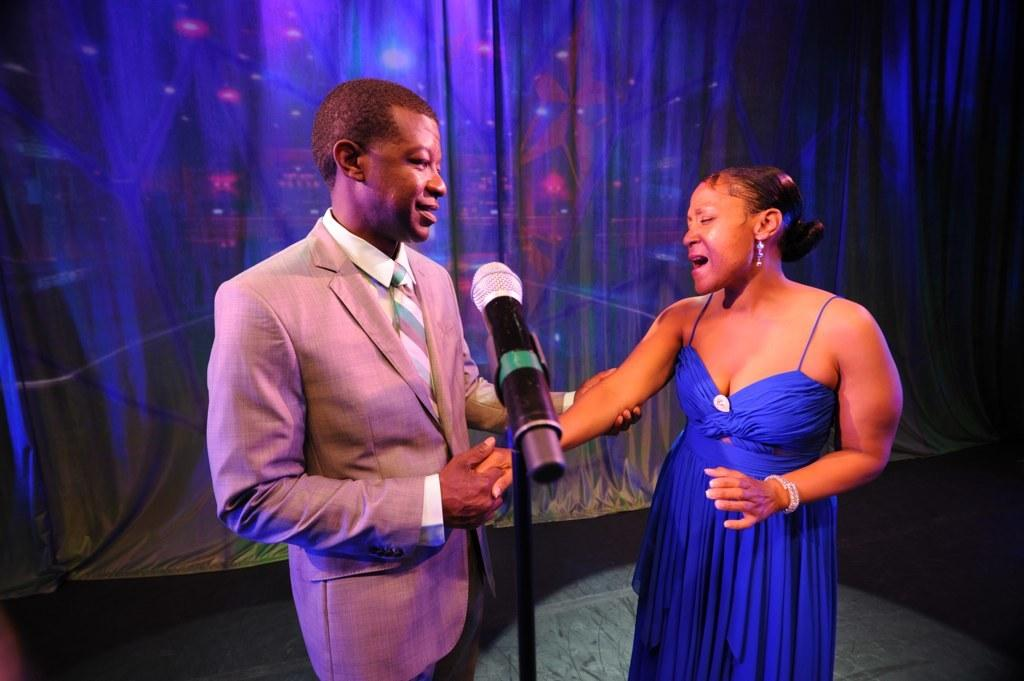What is the person in the image wearing? The person is wearing a suit in the image. What is the person doing in the image? The person is standing and holding the hand of a woman in front of him. What object is beside the person? There is a microphone beside the person. What color is the background of the image? The background of the image is blue. Can you see the person brushing their teeth in the image? No, there is no indication of the person brushing their teeth in the image. 